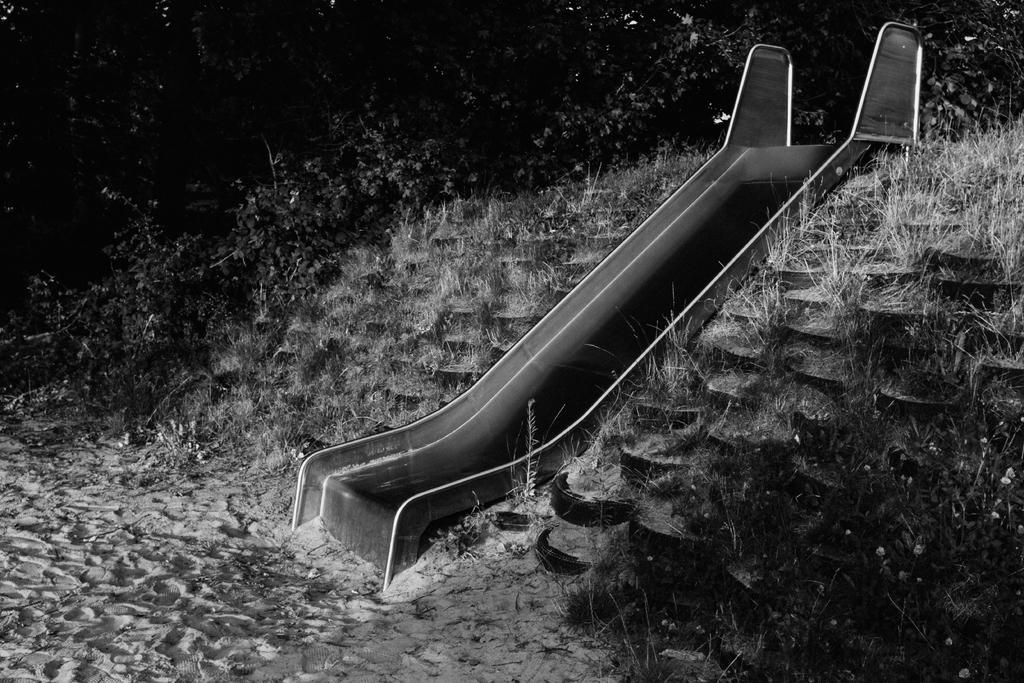What is the color scheme of the image? The image is black and white. What playground equipment can be seen in the image? There is a slide in the image. What type of surface is on the ground in the image? Grass is present on the ground in the image. What can be seen in the background of the image? There are trees in the background of the image. What type of hair can be seen on the slide in the image? There is no hair present on the slide in the image, as it is a playground equipment made of metal or plastic. 